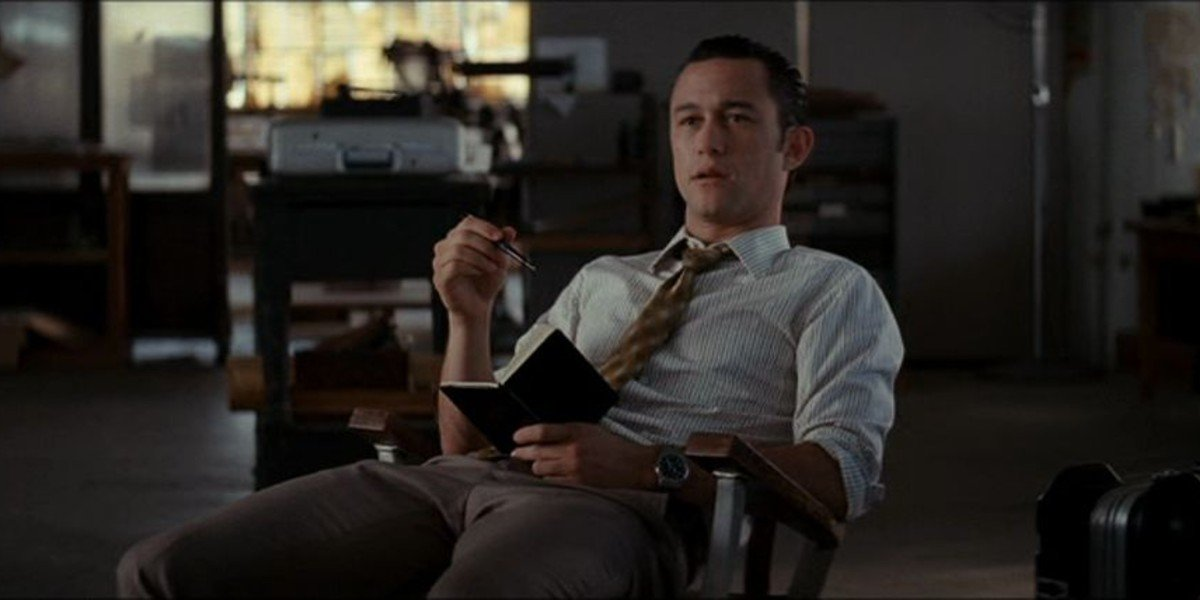What kind of book could he be holding? The black book in his hand could be many things – possibly a journal, a professional planner, or a book of notes and scripts. The earnest look on his face suggests it may contain important information related to his work or personal reflections he could be revisiting. 